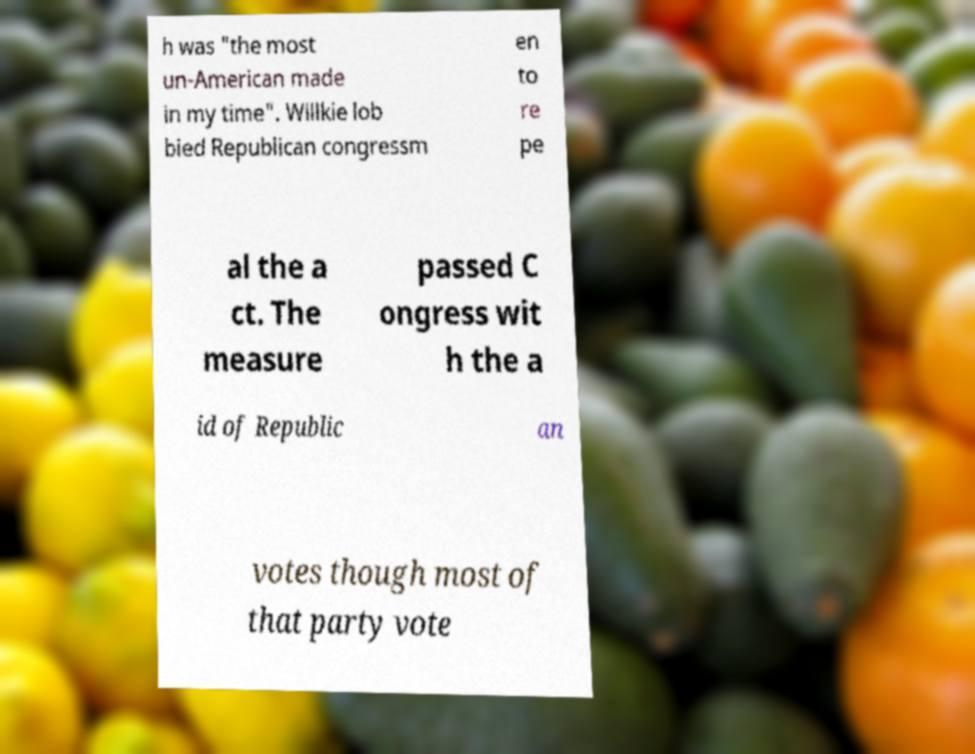I need the written content from this picture converted into text. Can you do that? h was "the most un-American made in my time". Willkie lob bied Republican congressm en to re pe al the a ct. The measure passed C ongress wit h the a id of Republic an votes though most of that party vote 